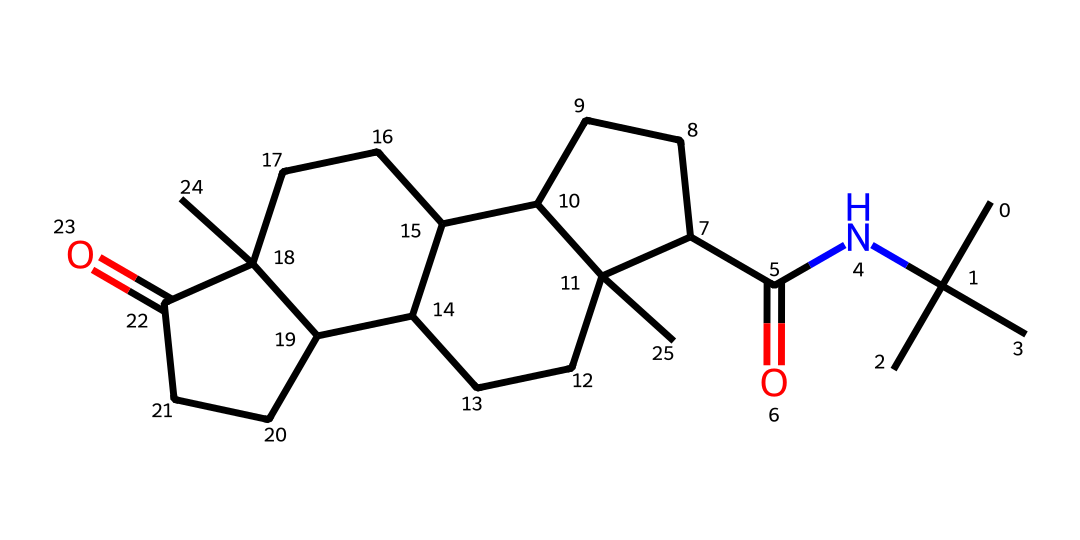What is the molecular formula of finasteride? To determine the molecular formula, we count the number of each type of atom in the SMILES notation. The components are carbon (C), hydrogen (H), nitrogen (N), and oxygen (O). After analyzing, we find 19 carbons, 26 hydrogens, 1 nitrogen, and 1 oxygen, which results in the molecular formula C19H26N2O.
Answer: C19H26N2O How many rings are present in the structure of finasteride? By examining the SMILES representation, we look for digits indicating ring closures. The digits 1, 2, and 3 are present, which represent the start and end of three separate rings; thus, there are 3 rings in the structure.
Answer: 3 What type of carbonyl group is present in the structure of finasteride? Finasteride contains a carbonyl functional group (C=O) that is part of a ketone structure. Since the carbonyl is linked to two carbon atoms, rather than being terminal (like in aldehydes), it is classified as a ketone.
Answer: ketone What is the total number of nitrogen atoms in finasteride? The SMILES representation includes the letter 'N', which denotes nitrogen atoms. By examining it, we find only one occurrence of 'N', indicating the presence of 1 nitrogen atom in finasteride.
Answer: 1 Considering the ketone functional group, how many carbon atoms are adjacent to it? The carbonyl (C=O) in ketones is flanked by carbons on both sides. In the SMILES structure, we can see two carbon atoms directly connected to the carbonyl carbon, hence there are 2 adjacent carbon atoms.
Answer: 2 